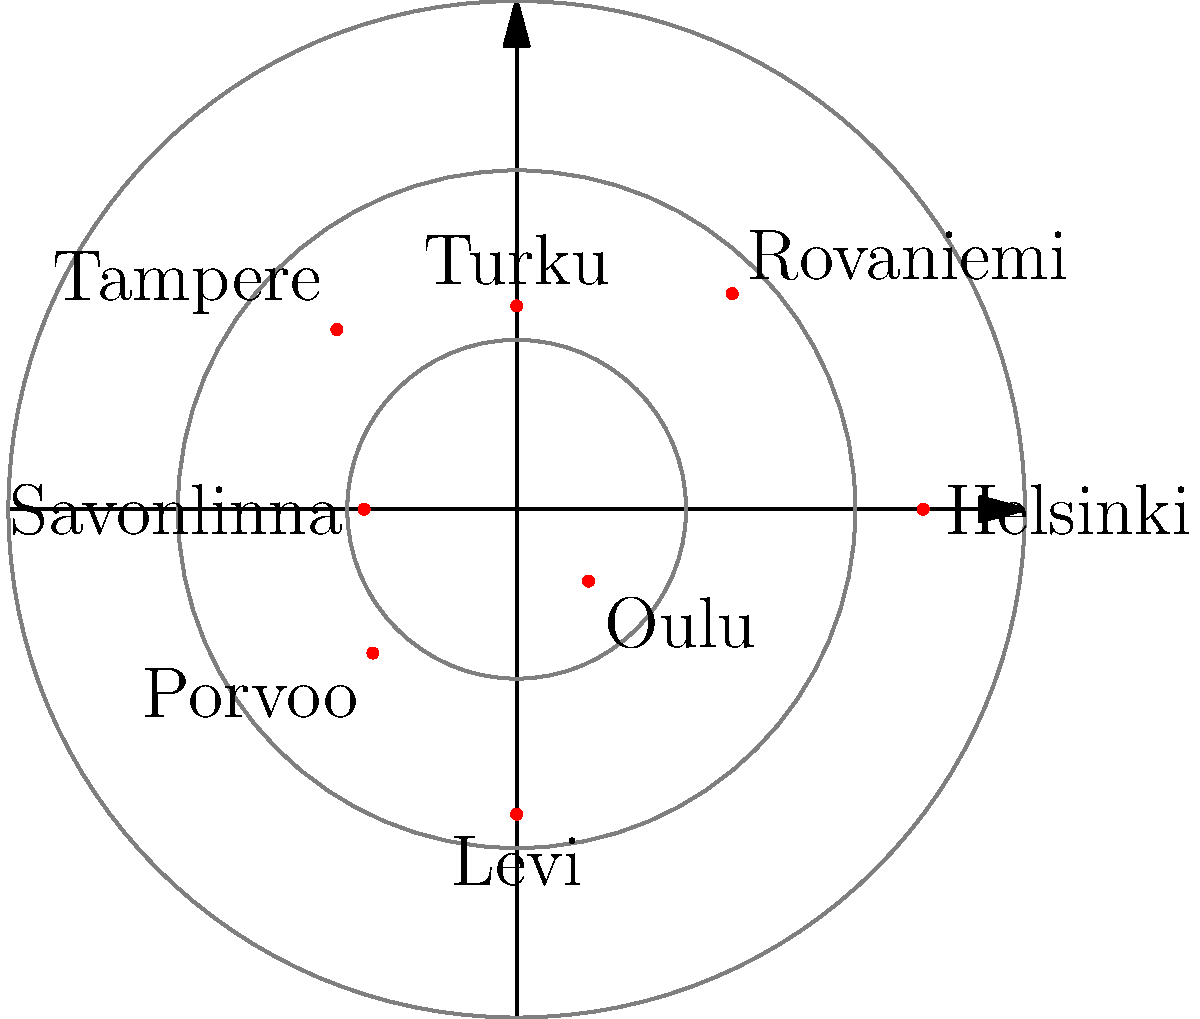In the polar coordinate system shown, popular Finnish tourist destinations are mapped based on their relative popularity (radial distance) and geographical direction from the center of Finland (angular position). Which destination is represented by the point closest to the origin, indicating it as the least popular among those shown? To solve this question, we need to follow these steps:

1. Understand the representation: In this polar coordinate system, the radial distance from the center represents the relative popularity of the destination, while the angular position represents its geographical direction from the center of Finland.

2. Identify the points: Each point on the graph represents a different Finnish tourist destination.

3. Compare the radial distances: The point closest to the origin (center) will have the shortest radial distance, indicating the least popular destination among those shown.

4. Examine each point:
   - Helsinki: (0°, 4)
   - Rovaniemi: (45°, 3)
   - Turku: (90°, 2)
   - Tampere: (135°, 2.5)
   - Savonlinna: (180°, 1.5)
   - Porvoo: (225°, 2)
   - Levi: (270°, 3)
   - Oulu: (315°, 1)

5. Identify the shortest radial distance: Oulu has the shortest radial distance of 1, placing it closest to the origin.

Therefore, Oulu is represented by the point closest to the origin, indicating it as the least popular destination among those shown in this representation.
Answer: Oulu 